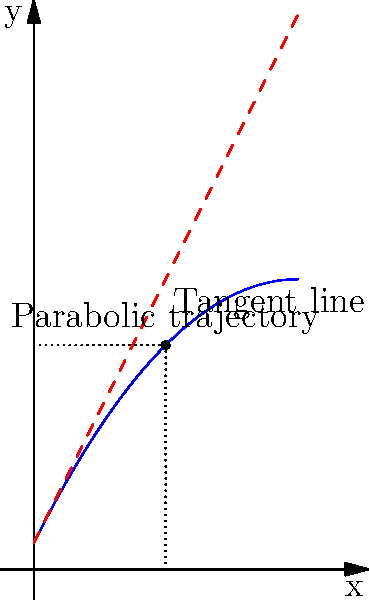In a crucial tennis match, you hit a perfect lob that follows a parabolic trajectory described by the equation $y = -0.1x^2 + 2x + 1$, where $x$ and $y$ are measured in meters. At what point does the ball reach its maximum height, and what is this height? To find the maximum height of the parabolic trajectory, we need to follow these steps:

1) The parabola's axis of symmetry gives us the x-coordinate of the vertex (maximum point). For a parabola $y = ax^2 + bx + c$, the x-coordinate of the vertex is given by $x = -\frac{b}{2a}$.

2) In our equation $y = -0.1x^2 + 2x + 1$, we have:
   $a = -0.1$
   $b = 2$
   $c = 1$

3) Substituting into the formula:
   $x = -\frac{2}{2(-0.1)} = -\frac{2}{-0.2} = 10$

4) To find the y-coordinate (maximum height), we substitute $x = 10$ into the original equation:
   $y = -0.1(10)^2 + 2(10) + 1$
   $y = -10 + 20 + 1$
   $y = 11$

5) Therefore, the ball reaches its maximum height at the point (10, 11).
Answer: (10, 11) meters 